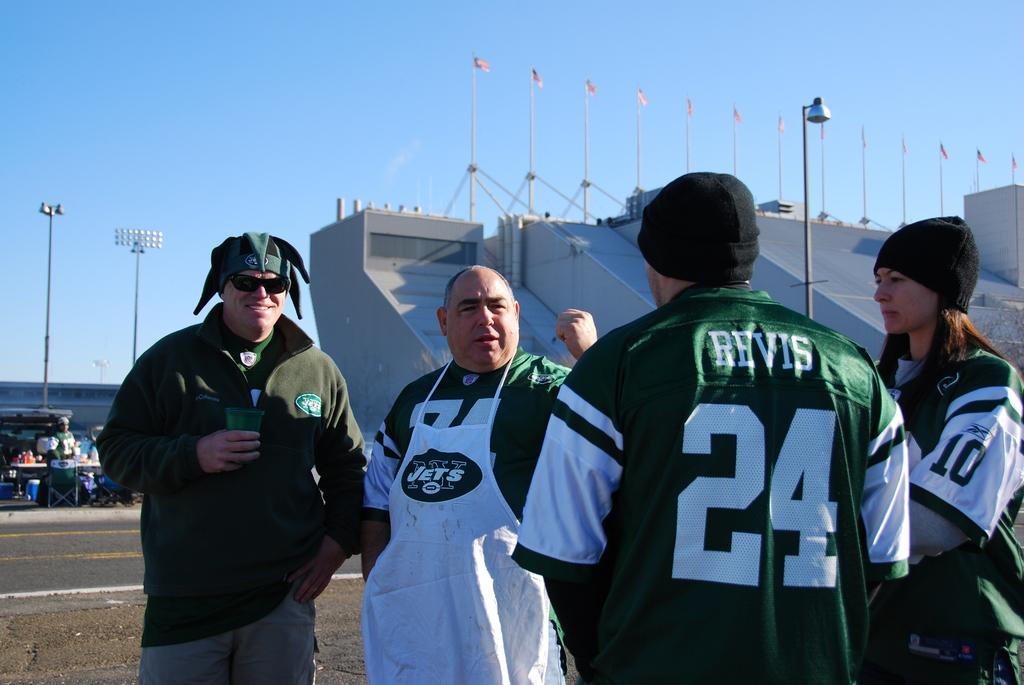What is the number on the woman's sleeve?
Offer a very short reply. 10. 